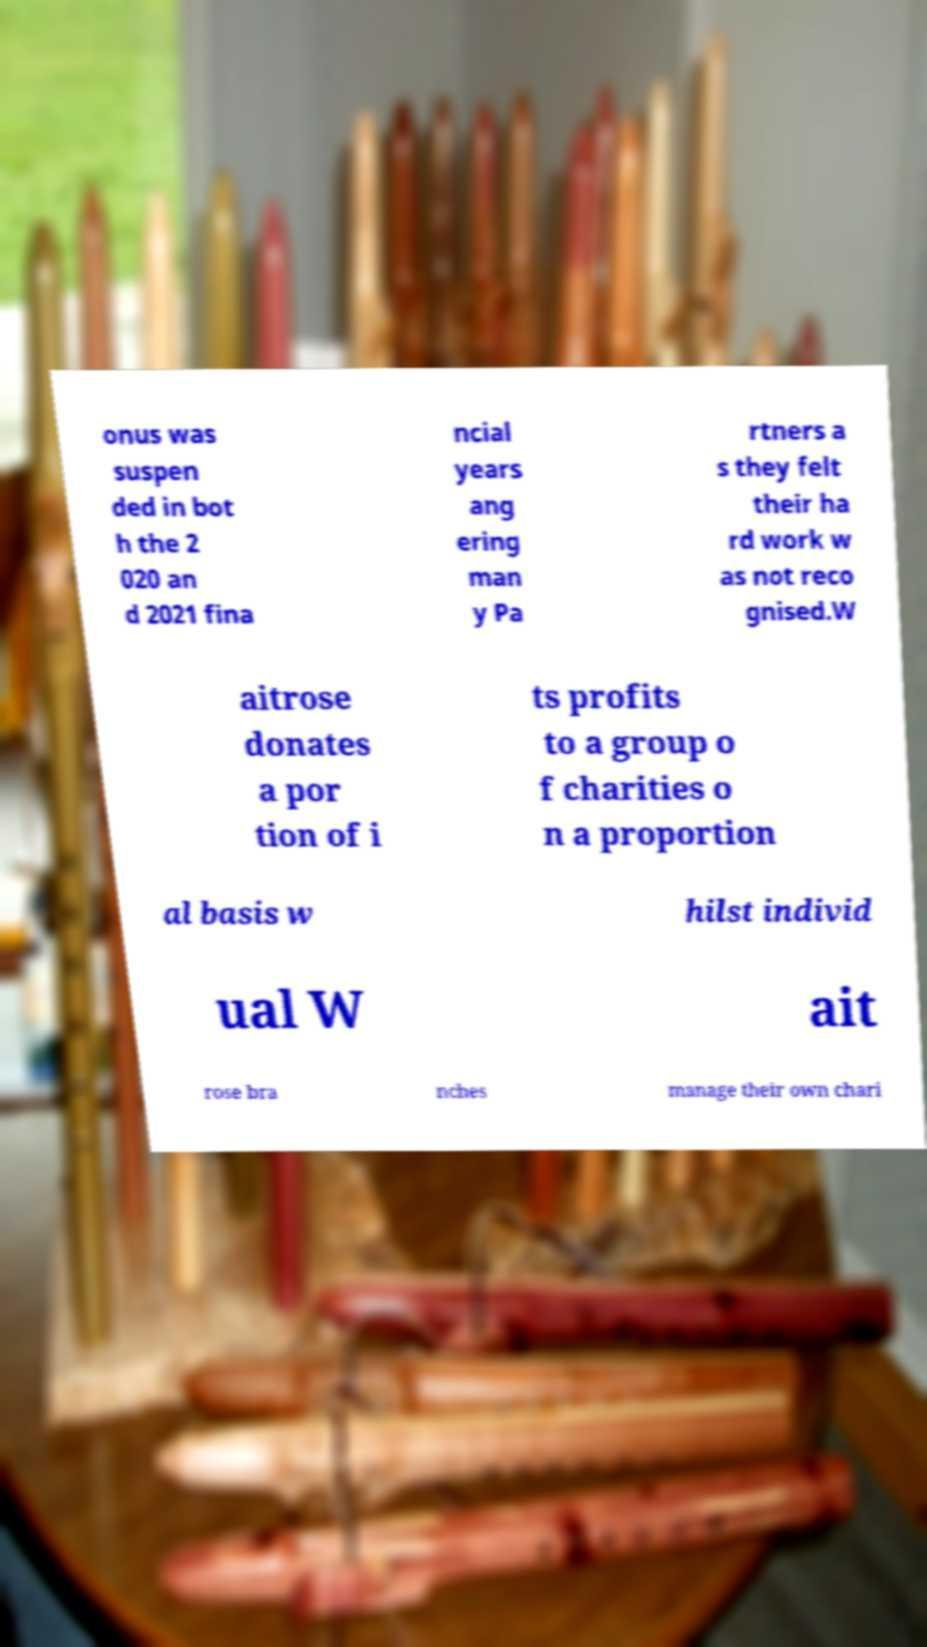Please read and relay the text visible in this image. What does it say? onus was suspen ded in bot h the 2 020 an d 2021 fina ncial years ang ering man y Pa rtners a s they felt their ha rd work w as not reco gnised.W aitrose donates a por tion of i ts profits to a group o f charities o n a proportion al basis w hilst individ ual W ait rose bra nches manage their own chari 